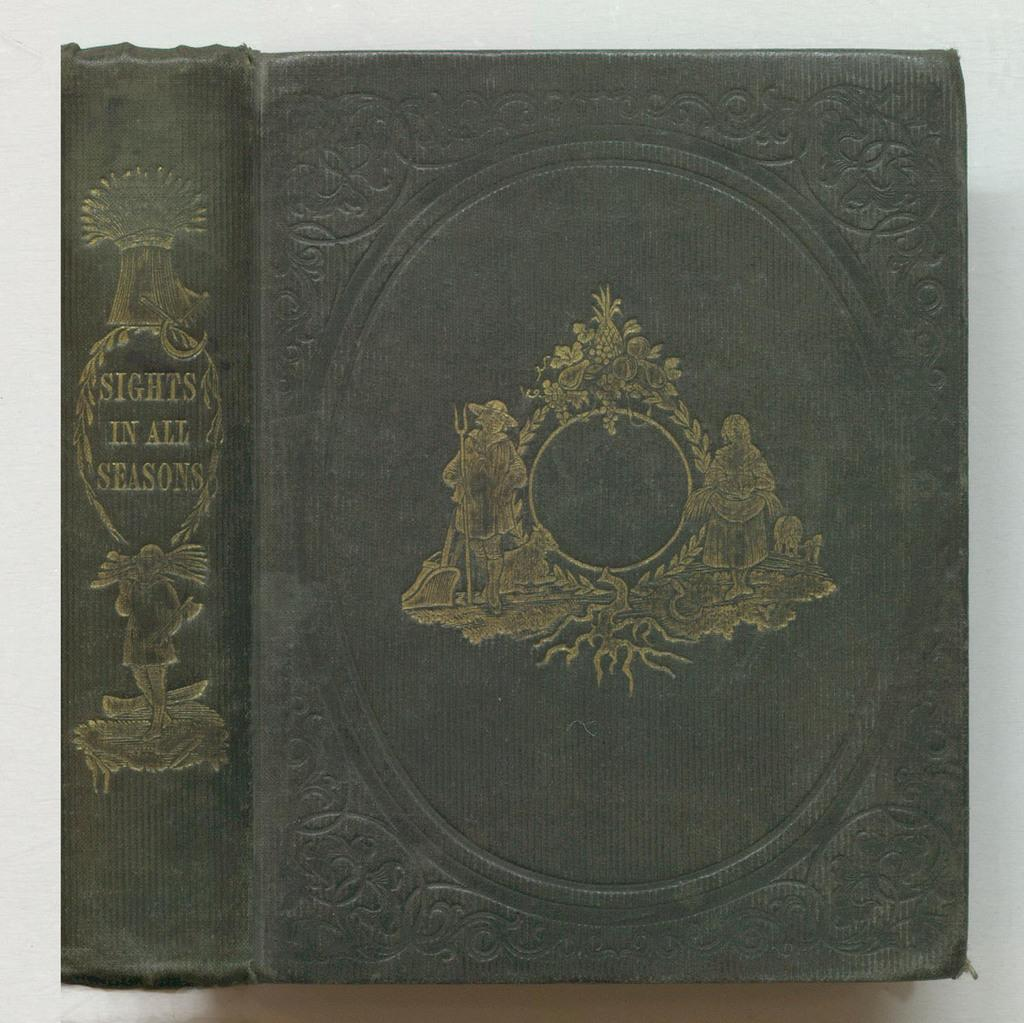<image>
Create a compact narrative representing the image presented. An old book with a green cover and gold embossing says Sights in All Seasons on the spine. 